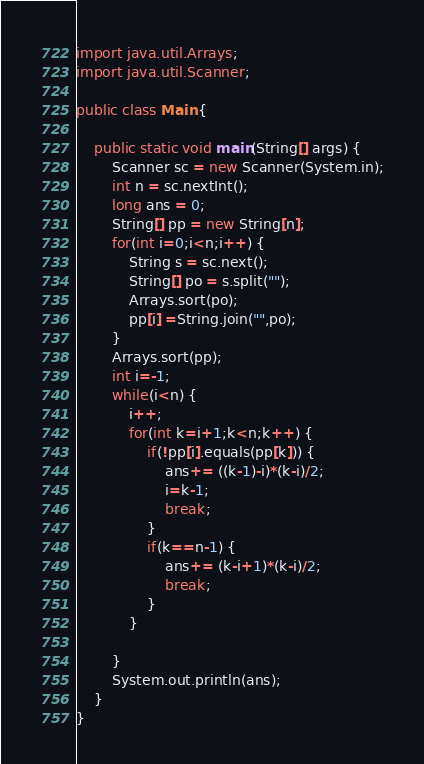Convert code to text. <code><loc_0><loc_0><loc_500><loc_500><_Java_>import java.util.Arrays;
import java.util.Scanner;

public class Main {

	public static void main(String[] args) {
		Scanner sc = new Scanner(System.in);
		int n = sc.nextInt();
		long ans = 0;
		String[] pp = new String[n];
		for(int i=0;i<n;i++) {
			String s = sc.next();
			String[] po = s.split(""); 
			Arrays.sort(po);
			pp[i] =String.join("",po);
		}
		Arrays.sort(pp);
		int i=-1;
		while(i<n) {
			i++;
			for(int k=i+1;k<n;k++) {
				if(!pp[i].equals(pp[k])) {
					ans+= ((k-1)-i)*(k-i)/2;
					i=k-1;
					break;
				}
				if(k==n-1) {
					ans+= (k-i+1)*(k-i)/2;
					break;
				}
			}
			
		}
		System.out.println(ans);
	}
}</code> 